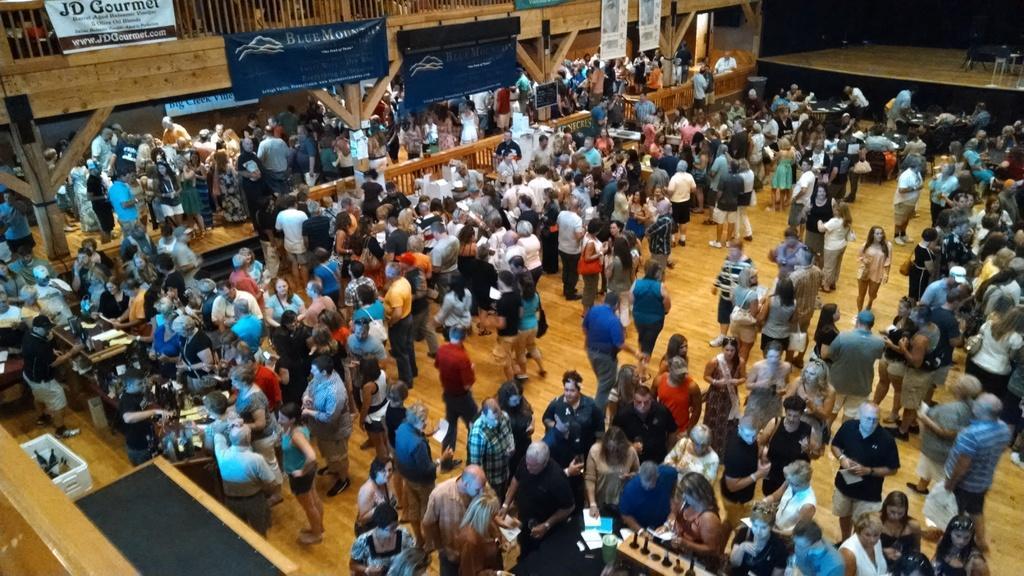Can you describe this image briefly? In the image there are many people standing. At the top of the image there is a railing with posters. And also there is a stage. 